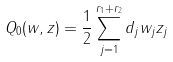<formula> <loc_0><loc_0><loc_500><loc_500>Q _ { 0 } ( w , z ) = \frac { 1 } { 2 } \sum _ { j = 1 } ^ { r _ { 1 } + r _ { 2 } } d _ { j } w _ { j } z _ { j }</formula> 